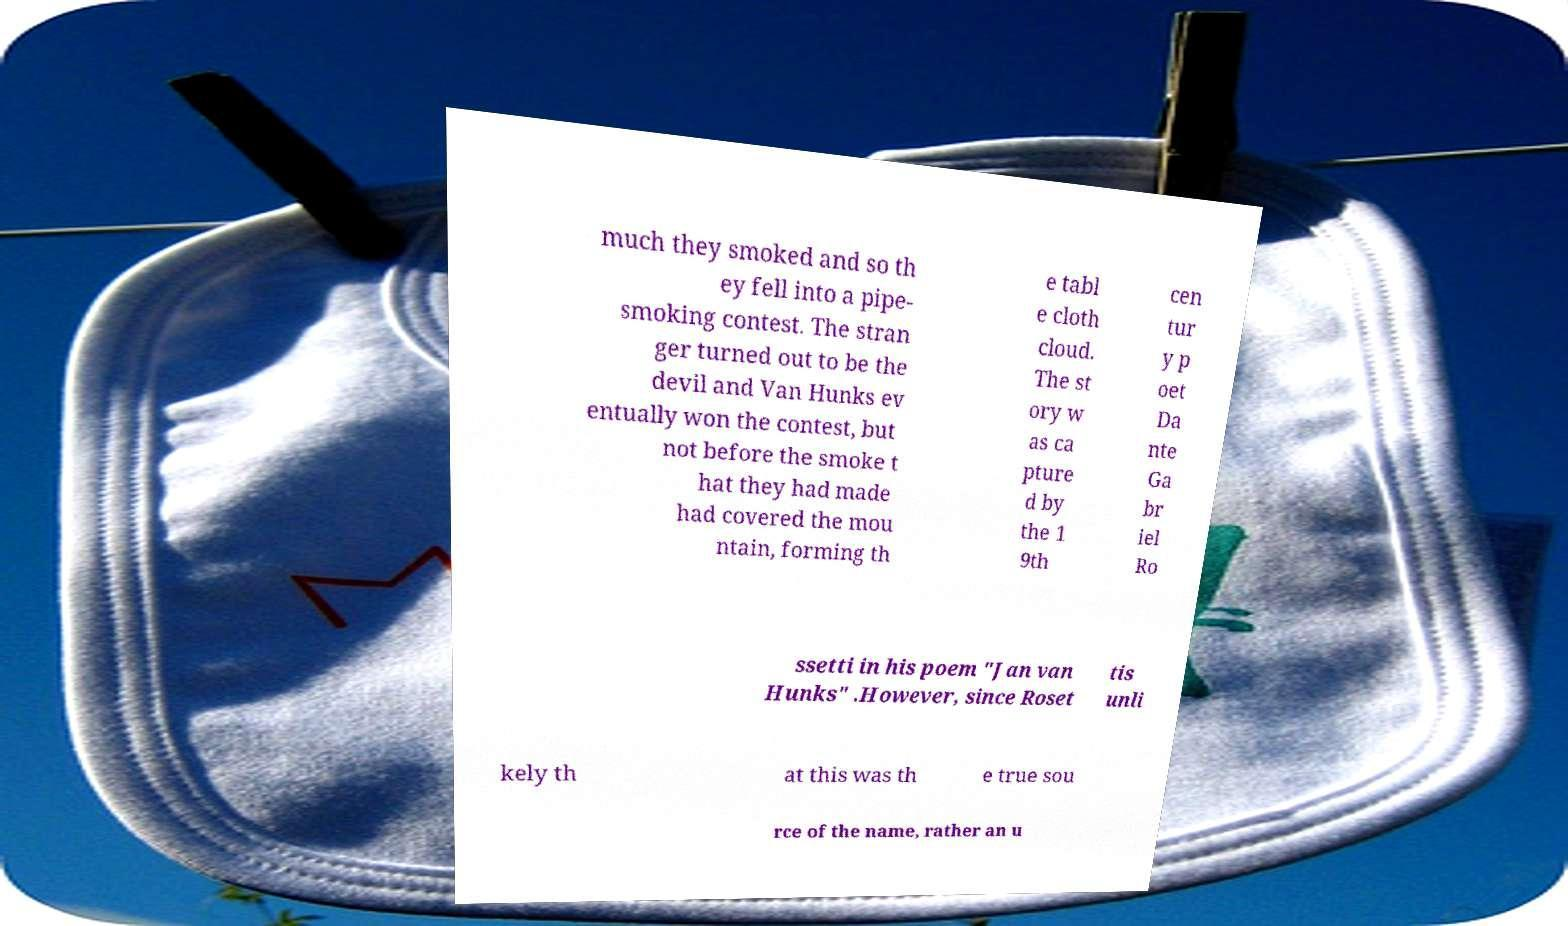For documentation purposes, I need the text within this image transcribed. Could you provide that? much they smoked and so th ey fell into a pipe- smoking contest. The stran ger turned out to be the devil and Van Hunks ev entually won the contest, but not before the smoke t hat they had made had covered the mou ntain, forming th e tabl e cloth cloud. The st ory w as ca pture d by the 1 9th cen tur y p oet Da nte Ga br iel Ro ssetti in his poem "Jan van Hunks" .However, since Roset tis unli kely th at this was th e true sou rce of the name, rather an u 